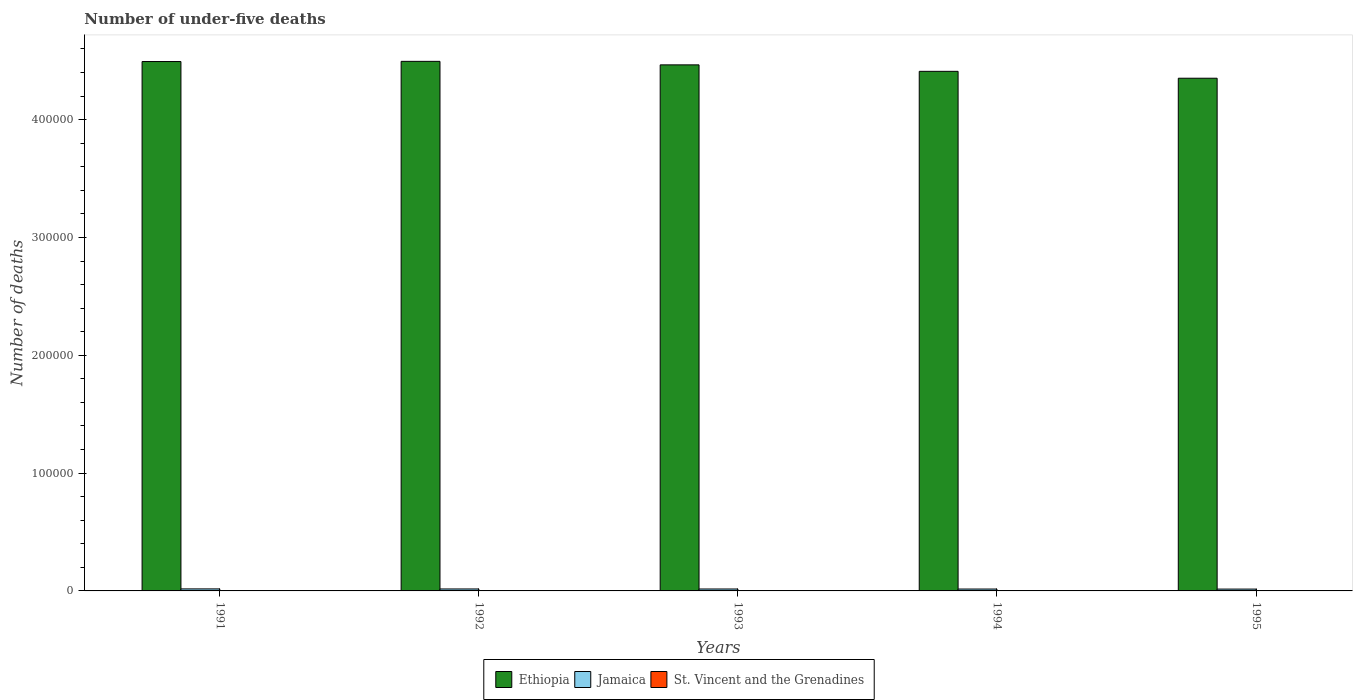How many different coloured bars are there?
Keep it short and to the point. 3. How many groups of bars are there?
Offer a terse response. 5. Are the number of bars on each tick of the X-axis equal?
Your answer should be compact. Yes. How many bars are there on the 2nd tick from the left?
Provide a succinct answer. 3. How many bars are there on the 5th tick from the right?
Make the answer very short. 3. What is the label of the 4th group of bars from the left?
Your response must be concise. 1994. In which year was the number of under-five deaths in Ethiopia maximum?
Offer a very short reply. 1992. What is the total number of under-five deaths in Ethiopia in the graph?
Offer a terse response. 2.22e+06. What is the difference between the number of under-five deaths in St. Vincent and the Grenadines in 1992 and that in 1995?
Make the answer very short. 3. What is the difference between the number of under-five deaths in Jamaica in 1991 and the number of under-five deaths in Ethiopia in 1994?
Your response must be concise. -4.39e+05. What is the average number of under-five deaths in Ethiopia per year?
Your answer should be compact. 4.44e+05. In the year 1992, what is the difference between the number of under-five deaths in Jamaica and number of under-five deaths in St. Vincent and the Grenadines?
Offer a terse response. 1606. What is the ratio of the number of under-five deaths in Ethiopia in 1992 to that in 1993?
Ensure brevity in your answer.  1.01. Is the difference between the number of under-five deaths in Jamaica in 1992 and 1994 greater than the difference between the number of under-five deaths in St. Vincent and the Grenadines in 1992 and 1994?
Your answer should be compact. Yes. What is the difference between the highest and the second highest number of under-five deaths in Ethiopia?
Your answer should be compact. 152. What is the difference between the highest and the lowest number of under-five deaths in Jamaica?
Offer a terse response. 149. Is the sum of the number of under-five deaths in Jamaica in 1991 and 1994 greater than the maximum number of under-five deaths in Ethiopia across all years?
Keep it short and to the point. No. What does the 3rd bar from the left in 1994 represents?
Your answer should be compact. St. Vincent and the Grenadines. What does the 3rd bar from the right in 1995 represents?
Keep it short and to the point. Ethiopia. How many bars are there?
Provide a short and direct response. 15. How many years are there in the graph?
Provide a short and direct response. 5. What is the difference between two consecutive major ticks on the Y-axis?
Provide a short and direct response. 1.00e+05. Does the graph contain any zero values?
Offer a very short reply. No. What is the title of the graph?
Offer a very short reply. Number of under-five deaths. What is the label or title of the X-axis?
Offer a very short reply. Years. What is the label or title of the Y-axis?
Keep it short and to the point. Number of deaths. What is the Number of deaths of Ethiopia in 1991?
Your answer should be very brief. 4.49e+05. What is the Number of deaths in Jamaica in 1991?
Make the answer very short. 1712. What is the Number of deaths in St. Vincent and the Grenadines in 1991?
Your answer should be very brief. 61. What is the Number of deaths in Ethiopia in 1992?
Your answer should be very brief. 4.49e+05. What is the Number of deaths of Jamaica in 1992?
Offer a very short reply. 1665. What is the Number of deaths of Ethiopia in 1993?
Offer a very short reply. 4.46e+05. What is the Number of deaths in Jamaica in 1993?
Keep it short and to the point. 1633. What is the Number of deaths in Ethiopia in 1994?
Offer a terse response. 4.41e+05. What is the Number of deaths in Jamaica in 1994?
Your answer should be very brief. 1603. What is the Number of deaths of St. Vincent and the Grenadines in 1994?
Offer a very short reply. 57. What is the Number of deaths of Ethiopia in 1995?
Offer a very short reply. 4.35e+05. What is the Number of deaths in Jamaica in 1995?
Make the answer very short. 1563. Across all years, what is the maximum Number of deaths of Ethiopia?
Provide a short and direct response. 4.49e+05. Across all years, what is the maximum Number of deaths in Jamaica?
Ensure brevity in your answer.  1712. Across all years, what is the minimum Number of deaths of Ethiopia?
Offer a terse response. 4.35e+05. Across all years, what is the minimum Number of deaths in Jamaica?
Provide a short and direct response. 1563. Across all years, what is the minimum Number of deaths of St. Vincent and the Grenadines?
Provide a short and direct response. 56. What is the total Number of deaths of Ethiopia in the graph?
Keep it short and to the point. 2.22e+06. What is the total Number of deaths in Jamaica in the graph?
Your answer should be very brief. 8176. What is the total Number of deaths of St. Vincent and the Grenadines in the graph?
Give a very brief answer. 291. What is the difference between the Number of deaths of Ethiopia in 1991 and that in 1992?
Give a very brief answer. -152. What is the difference between the Number of deaths of Jamaica in 1991 and that in 1992?
Provide a succinct answer. 47. What is the difference between the Number of deaths of Ethiopia in 1991 and that in 1993?
Give a very brief answer. 2825. What is the difference between the Number of deaths in Jamaica in 1991 and that in 1993?
Keep it short and to the point. 79. What is the difference between the Number of deaths of St. Vincent and the Grenadines in 1991 and that in 1993?
Your answer should be compact. 3. What is the difference between the Number of deaths in Ethiopia in 1991 and that in 1994?
Offer a terse response. 8325. What is the difference between the Number of deaths of Jamaica in 1991 and that in 1994?
Make the answer very short. 109. What is the difference between the Number of deaths in St. Vincent and the Grenadines in 1991 and that in 1994?
Provide a short and direct response. 4. What is the difference between the Number of deaths in Ethiopia in 1991 and that in 1995?
Your response must be concise. 1.42e+04. What is the difference between the Number of deaths of Jamaica in 1991 and that in 1995?
Give a very brief answer. 149. What is the difference between the Number of deaths of Ethiopia in 1992 and that in 1993?
Your response must be concise. 2977. What is the difference between the Number of deaths of Ethiopia in 1992 and that in 1994?
Give a very brief answer. 8477. What is the difference between the Number of deaths in Jamaica in 1992 and that in 1994?
Provide a short and direct response. 62. What is the difference between the Number of deaths in St. Vincent and the Grenadines in 1992 and that in 1994?
Your answer should be compact. 2. What is the difference between the Number of deaths of Ethiopia in 1992 and that in 1995?
Offer a terse response. 1.43e+04. What is the difference between the Number of deaths of Jamaica in 1992 and that in 1995?
Your answer should be compact. 102. What is the difference between the Number of deaths of Ethiopia in 1993 and that in 1994?
Your response must be concise. 5500. What is the difference between the Number of deaths in Ethiopia in 1993 and that in 1995?
Provide a short and direct response. 1.13e+04. What is the difference between the Number of deaths in Jamaica in 1993 and that in 1995?
Provide a short and direct response. 70. What is the difference between the Number of deaths in Ethiopia in 1994 and that in 1995?
Offer a terse response. 5848. What is the difference between the Number of deaths in Jamaica in 1994 and that in 1995?
Your response must be concise. 40. What is the difference between the Number of deaths of St. Vincent and the Grenadines in 1994 and that in 1995?
Keep it short and to the point. 1. What is the difference between the Number of deaths in Ethiopia in 1991 and the Number of deaths in Jamaica in 1992?
Ensure brevity in your answer.  4.48e+05. What is the difference between the Number of deaths in Ethiopia in 1991 and the Number of deaths in St. Vincent and the Grenadines in 1992?
Provide a short and direct response. 4.49e+05. What is the difference between the Number of deaths of Jamaica in 1991 and the Number of deaths of St. Vincent and the Grenadines in 1992?
Provide a succinct answer. 1653. What is the difference between the Number of deaths in Ethiopia in 1991 and the Number of deaths in Jamaica in 1993?
Your answer should be compact. 4.48e+05. What is the difference between the Number of deaths in Ethiopia in 1991 and the Number of deaths in St. Vincent and the Grenadines in 1993?
Provide a short and direct response. 4.49e+05. What is the difference between the Number of deaths of Jamaica in 1991 and the Number of deaths of St. Vincent and the Grenadines in 1993?
Make the answer very short. 1654. What is the difference between the Number of deaths of Ethiopia in 1991 and the Number of deaths of Jamaica in 1994?
Provide a succinct answer. 4.48e+05. What is the difference between the Number of deaths of Ethiopia in 1991 and the Number of deaths of St. Vincent and the Grenadines in 1994?
Offer a terse response. 4.49e+05. What is the difference between the Number of deaths in Jamaica in 1991 and the Number of deaths in St. Vincent and the Grenadines in 1994?
Keep it short and to the point. 1655. What is the difference between the Number of deaths of Ethiopia in 1991 and the Number of deaths of Jamaica in 1995?
Provide a short and direct response. 4.48e+05. What is the difference between the Number of deaths of Ethiopia in 1991 and the Number of deaths of St. Vincent and the Grenadines in 1995?
Provide a short and direct response. 4.49e+05. What is the difference between the Number of deaths of Jamaica in 1991 and the Number of deaths of St. Vincent and the Grenadines in 1995?
Make the answer very short. 1656. What is the difference between the Number of deaths of Ethiopia in 1992 and the Number of deaths of Jamaica in 1993?
Make the answer very short. 4.48e+05. What is the difference between the Number of deaths of Ethiopia in 1992 and the Number of deaths of St. Vincent and the Grenadines in 1993?
Offer a terse response. 4.49e+05. What is the difference between the Number of deaths of Jamaica in 1992 and the Number of deaths of St. Vincent and the Grenadines in 1993?
Provide a succinct answer. 1607. What is the difference between the Number of deaths of Ethiopia in 1992 and the Number of deaths of Jamaica in 1994?
Give a very brief answer. 4.48e+05. What is the difference between the Number of deaths in Ethiopia in 1992 and the Number of deaths in St. Vincent and the Grenadines in 1994?
Make the answer very short. 4.49e+05. What is the difference between the Number of deaths in Jamaica in 1992 and the Number of deaths in St. Vincent and the Grenadines in 1994?
Offer a terse response. 1608. What is the difference between the Number of deaths of Ethiopia in 1992 and the Number of deaths of Jamaica in 1995?
Provide a succinct answer. 4.48e+05. What is the difference between the Number of deaths in Ethiopia in 1992 and the Number of deaths in St. Vincent and the Grenadines in 1995?
Make the answer very short. 4.49e+05. What is the difference between the Number of deaths of Jamaica in 1992 and the Number of deaths of St. Vincent and the Grenadines in 1995?
Your answer should be compact. 1609. What is the difference between the Number of deaths in Ethiopia in 1993 and the Number of deaths in Jamaica in 1994?
Your response must be concise. 4.45e+05. What is the difference between the Number of deaths of Ethiopia in 1993 and the Number of deaths of St. Vincent and the Grenadines in 1994?
Provide a succinct answer. 4.46e+05. What is the difference between the Number of deaths of Jamaica in 1993 and the Number of deaths of St. Vincent and the Grenadines in 1994?
Your response must be concise. 1576. What is the difference between the Number of deaths of Ethiopia in 1993 and the Number of deaths of Jamaica in 1995?
Your answer should be very brief. 4.45e+05. What is the difference between the Number of deaths of Ethiopia in 1993 and the Number of deaths of St. Vincent and the Grenadines in 1995?
Keep it short and to the point. 4.46e+05. What is the difference between the Number of deaths of Jamaica in 1993 and the Number of deaths of St. Vincent and the Grenadines in 1995?
Offer a terse response. 1577. What is the difference between the Number of deaths of Ethiopia in 1994 and the Number of deaths of Jamaica in 1995?
Offer a very short reply. 4.39e+05. What is the difference between the Number of deaths in Ethiopia in 1994 and the Number of deaths in St. Vincent and the Grenadines in 1995?
Your response must be concise. 4.41e+05. What is the difference between the Number of deaths of Jamaica in 1994 and the Number of deaths of St. Vincent and the Grenadines in 1995?
Your answer should be compact. 1547. What is the average Number of deaths in Ethiopia per year?
Ensure brevity in your answer.  4.44e+05. What is the average Number of deaths in Jamaica per year?
Provide a short and direct response. 1635.2. What is the average Number of deaths of St. Vincent and the Grenadines per year?
Provide a succinct answer. 58.2. In the year 1991, what is the difference between the Number of deaths of Ethiopia and Number of deaths of Jamaica?
Offer a very short reply. 4.48e+05. In the year 1991, what is the difference between the Number of deaths of Ethiopia and Number of deaths of St. Vincent and the Grenadines?
Your response must be concise. 4.49e+05. In the year 1991, what is the difference between the Number of deaths of Jamaica and Number of deaths of St. Vincent and the Grenadines?
Ensure brevity in your answer.  1651. In the year 1992, what is the difference between the Number of deaths of Ethiopia and Number of deaths of Jamaica?
Provide a succinct answer. 4.48e+05. In the year 1992, what is the difference between the Number of deaths of Ethiopia and Number of deaths of St. Vincent and the Grenadines?
Your response must be concise. 4.49e+05. In the year 1992, what is the difference between the Number of deaths of Jamaica and Number of deaths of St. Vincent and the Grenadines?
Offer a terse response. 1606. In the year 1993, what is the difference between the Number of deaths in Ethiopia and Number of deaths in Jamaica?
Offer a very short reply. 4.45e+05. In the year 1993, what is the difference between the Number of deaths of Ethiopia and Number of deaths of St. Vincent and the Grenadines?
Ensure brevity in your answer.  4.46e+05. In the year 1993, what is the difference between the Number of deaths in Jamaica and Number of deaths in St. Vincent and the Grenadines?
Keep it short and to the point. 1575. In the year 1994, what is the difference between the Number of deaths of Ethiopia and Number of deaths of Jamaica?
Your response must be concise. 4.39e+05. In the year 1994, what is the difference between the Number of deaths of Ethiopia and Number of deaths of St. Vincent and the Grenadines?
Ensure brevity in your answer.  4.41e+05. In the year 1994, what is the difference between the Number of deaths of Jamaica and Number of deaths of St. Vincent and the Grenadines?
Offer a very short reply. 1546. In the year 1995, what is the difference between the Number of deaths of Ethiopia and Number of deaths of Jamaica?
Provide a short and direct response. 4.34e+05. In the year 1995, what is the difference between the Number of deaths of Ethiopia and Number of deaths of St. Vincent and the Grenadines?
Offer a very short reply. 4.35e+05. In the year 1995, what is the difference between the Number of deaths of Jamaica and Number of deaths of St. Vincent and the Grenadines?
Provide a short and direct response. 1507. What is the ratio of the Number of deaths in Ethiopia in 1991 to that in 1992?
Your answer should be very brief. 1. What is the ratio of the Number of deaths in Jamaica in 1991 to that in 1992?
Your response must be concise. 1.03. What is the ratio of the Number of deaths in St. Vincent and the Grenadines in 1991 to that in 1992?
Ensure brevity in your answer.  1.03. What is the ratio of the Number of deaths in Ethiopia in 1991 to that in 1993?
Offer a very short reply. 1.01. What is the ratio of the Number of deaths in Jamaica in 1991 to that in 1993?
Your answer should be compact. 1.05. What is the ratio of the Number of deaths of St. Vincent and the Grenadines in 1991 to that in 1993?
Your answer should be very brief. 1.05. What is the ratio of the Number of deaths in Ethiopia in 1991 to that in 1994?
Make the answer very short. 1.02. What is the ratio of the Number of deaths of Jamaica in 1991 to that in 1994?
Provide a short and direct response. 1.07. What is the ratio of the Number of deaths in St. Vincent and the Grenadines in 1991 to that in 1994?
Make the answer very short. 1.07. What is the ratio of the Number of deaths in Ethiopia in 1991 to that in 1995?
Ensure brevity in your answer.  1.03. What is the ratio of the Number of deaths in Jamaica in 1991 to that in 1995?
Provide a short and direct response. 1.1. What is the ratio of the Number of deaths of St. Vincent and the Grenadines in 1991 to that in 1995?
Your response must be concise. 1.09. What is the ratio of the Number of deaths in Jamaica in 1992 to that in 1993?
Offer a terse response. 1.02. What is the ratio of the Number of deaths in St. Vincent and the Grenadines in 1992 to that in 1993?
Keep it short and to the point. 1.02. What is the ratio of the Number of deaths in Ethiopia in 1992 to that in 1994?
Give a very brief answer. 1.02. What is the ratio of the Number of deaths in Jamaica in 1992 to that in 1994?
Your response must be concise. 1.04. What is the ratio of the Number of deaths in St. Vincent and the Grenadines in 1992 to that in 1994?
Your answer should be compact. 1.04. What is the ratio of the Number of deaths of Ethiopia in 1992 to that in 1995?
Offer a very short reply. 1.03. What is the ratio of the Number of deaths of Jamaica in 1992 to that in 1995?
Ensure brevity in your answer.  1.07. What is the ratio of the Number of deaths in St. Vincent and the Grenadines in 1992 to that in 1995?
Make the answer very short. 1.05. What is the ratio of the Number of deaths in Ethiopia in 1993 to that in 1994?
Keep it short and to the point. 1.01. What is the ratio of the Number of deaths in Jamaica in 1993 to that in 1994?
Provide a short and direct response. 1.02. What is the ratio of the Number of deaths in St. Vincent and the Grenadines in 1993 to that in 1994?
Offer a terse response. 1.02. What is the ratio of the Number of deaths of Ethiopia in 1993 to that in 1995?
Your answer should be very brief. 1.03. What is the ratio of the Number of deaths in Jamaica in 1993 to that in 1995?
Make the answer very short. 1.04. What is the ratio of the Number of deaths in St. Vincent and the Grenadines in 1993 to that in 1995?
Provide a succinct answer. 1.04. What is the ratio of the Number of deaths of Ethiopia in 1994 to that in 1995?
Your answer should be very brief. 1.01. What is the ratio of the Number of deaths in Jamaica in 1994 to that in 1995?
Ensure brevity in your answer.  1.03. What is the ratio of the Number of deaths of St. Vincent and the Grenadines in 1994 to that in 1995?
Keep it short and to the point. 1.02. What is the difference between the highest and the second highest Number of deaths of Ethiopia?
Keep it short and to the point. 152. What is the difference between the highest and the second highest Number of deaths of Jamaica?
Offer a terse response. 47. What is the difference between the highest and the lowest Number of deaths in Ethiopia?
Provide a succinct answer. 1.43e+04. What is the difference between the highest and the lowest Number of deaths of Jamaica?
Keep it short and to the point. 149. 